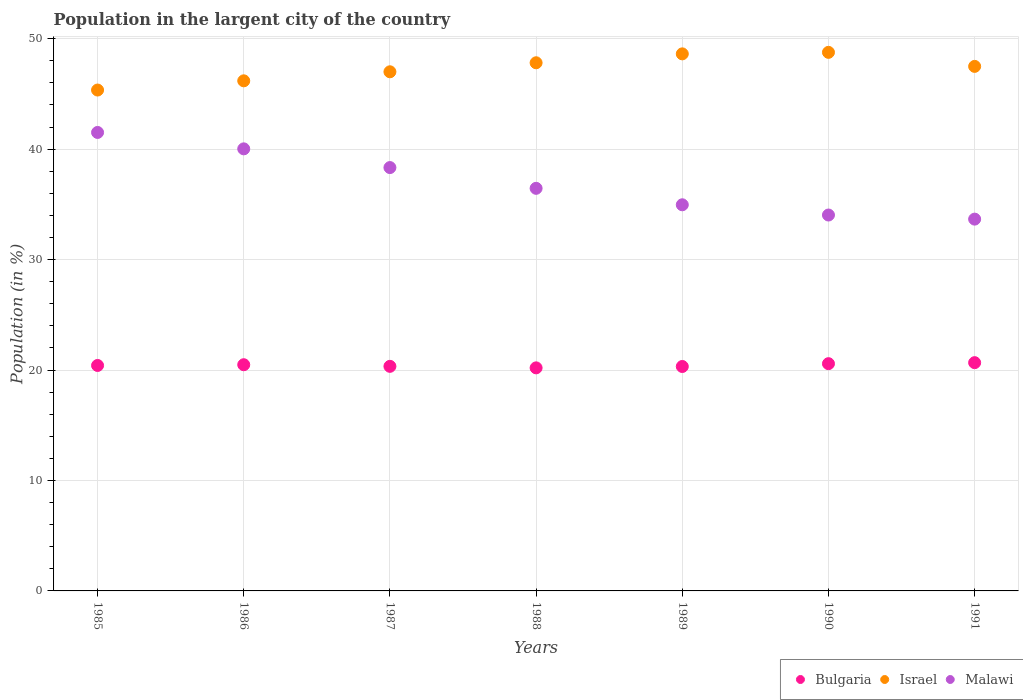How many different coloured dotlines are there?
Your answer should be very brief. 3. What is the percentage of population in the largent city in Israel in 1990?
Keep it short and to the point. 48.77. Across all years, what is the maximum percentage of population in the largent city in Bulgaria?
Ensure brevity in your answer.  20.67. Across all years, what is the minimum percentage of population in the largent city in Israel?
Your answer should be compact. 45.35. In which year was the percentage of population in the largent city in Israel maximum?
Offer a terse response. 1990. What is the total percentage of population in the largent city in Israel in the graph?
Give a very brief answer. 331.25. What is the difference between the percentage of population in the largent city in Israel in 1987 and that in 1990?
Your answer should be very brief. -1.76. What is the difference between the percentage of population in the largent city in Malawi in 1986 and the percentage of population in the largent city in Israel in 1990?
Provide a short and direct response. -8.74. What is the average percentage of population in the largent city in Bulgaria per year?
Offer a terse response. 20.43. In the year 1988, what is the difference between the percentage of population in the largent city in Israel and percentage of population in the largent city in Malawi?
Keep it short and to the point. 11.37. What is the ratio of the percentage of population in the largent city in Israel in 1986 to that in 1989?
Provide a short and direct response. 0.95. Is the difference between the percentage of population in the largent city in Israel in 1987 and 1989 greater than the difference between the percentage of population in the largent city in Malawi in 1987 and 1989?
Give a very brief answer. No. What is the difference between the highest and the second highest percentage of population in the largent city in Malawi?
Provide a short and direct response. 1.49. What is the difference between the highest and the lowest percentage of population in the largent city in Bulgaria?
Ensure brevity in your answer.  0.47. Is the sum of the percentage of population in the largent city in Israel in 1987 and 1991 greater than the maximum percentage of population in the largent city in Malawi across all years?
Your response must be concise. Yes. Is it the case that in every year, the sum of the percentage of population in the largent city in Malawi and percentage of population in the largent city in Israel  is greater than the percentage of population in the largent city in Bulgaria?
Your answer should be compact. Yes. Is the percentage of population in the largent city in Bulgaria strictly greater than the percentage of population in the largent city in Malawi over the years?
Your answer should be very brief. No. Is the percentage of population in the largent city in Israel strictly less than the percentage of population in the largent city in Bulgaria over the years?
Give a very brief answer. No. What is the difference between two consecutive major ticks on the Y-axis?
Offer a very short reply. 10. Are the values on the major ticks of Y-axis written in scientific E-notation?
Make the answer very short. No. Does the graph contain grids?
Your answer should be compact. Yes. Where does the legend appear in the graph?
Provide a short and direct response. Bottom right. How many legend labels are there?
Your response must be concise. 3. How are the legend labels stacked?
Offer a very short reply. Horizontal. What is the title of the graph?
Keep it short and to the point. Population in the largent city of the country. Does "Venezuela" appear as one of the legend labels in the graph?
Give a very brief answer. No. What is the label or title of the X-axis?
Provide a short and direct response. Years. What is the label or title of the Y-axis?
Ensure brevity in your answer.  Population (in %). What is the Population (in %) in Bulgaria in 1985?
Your response must be concise. 20.41. What is the Population (in %) in Israel in 1985?
Offer a terse response. 45.35. What is the Population (in %) of Malawi in 1985?
Provide a short and direct response. 41.51. What is the Population (in %) in Bulgaria in 1986?
Offer a terse response. 20.48. What is the Population (in %) in Israel in 1986?
Your answer should be compact. 46.19. What is the Population (in %) in Malawi in 1986?
Your answer should be compact. 40.03. What is the Population (in %) of Bulgaria in 1987?
Your response must be concise. 20.33. What is the Population (in %) of Israel in 1987?
Offer a terse response. 47.01. What is the Population (in %) of Malawi in 1987?
Offer a very short reply. 38.33. What is the Population (in %) of Bulgaria in 1988?
Your response must be concise. 20.2. What is the Population (in %) of Israel in 1988?
Your answer should be very brief. 47.82. What is the Population (in %) in Malawi in 1988?
Your response must be concise. 36.45. What is the Population (in %) of Bulgaria in 1989?
Give a very brief answer. 20.32. What is the Population (in %) in Israel in 1989?
Provide a short and direct response. 48.63. What is the Population (in %) of Malawi in 1989?
Give a very brief answer. 34.96. What is the Population (in %) of Bulgaria in 1990?
Provide a succinct answer. 20.58. What is the Population (in %) of Israel in 1990?
Give a very brief answer. 48.77. What is the Population (in %) of Malawi in 1990?
Your response must be concise. 34.04. What is the Population (in %) of Bulgaria in 1991?
Offer a terse response. 20.67. What is the Population (in %) of Israel in 1991?
Your answer should be very brief. 47.49. What is the Population (in %) in Malawi in 1991?
Offer a very short reply. 33.66. Across all years, what is the maximum Population (in %) in Bulgaria?
Keep it short and to the point. 20.67. Across all years, what is the maximum Population (in %) of Israel?
Your answer should be compact. 48.77. Across all years, what is the maximum Population (in %) in Malawi?
Make the answer very short. 41.51. Across all years, what is the minimum Population (in %) of Bulgaria?
Give a very brief answer. 20.2. Across all years, what is the minimum Population (in %) in Israel?
Keep it short and to the point. 45.35. Across all years, what is the minimum Population (in %) of Malawi?
Your answer should be very brief. 33.66. What is the total Population (in %) of Bulgaria in the graph?
Give a very brief answer. 142.99. What is the total Population (in %) in Israel in the graph?
Your answer should be compact. 331.25. What is the total Population (in %) in Malawi in the graph?
Make the answer very short. 258.99. What is the difference between the Population (in %) of Bulgaria in 1985 and that in 1986?
Ensure brevity in your answer.  -0.07. What is the difference between the Population (in %) of Israel in 1985 and that in 1986?
Keep it short and to the point. -0.83. What is the difference between the Population (in %) in Malawi in 1985 and that in 1986?
Make the answer very short. 1.49. What is the difference between the Population (in %) in Bulgaria in 1985 and that in 1987?
Your answer should be very brief. 0.08. What is the difference between the Population (in %) in Israel in 1985 and that in 1987?
Make the answer very short. -1.65. What is the difference between the Population (in %) of Malawi in 1985 and that in 1987?
Keep it short and to the point. 3.18. What is the difference between the Population (in %) of Bulgaria in 1985 and that in 1988?
Provide a short and direct response. 0.22. What is the difference between the Population (in %) in Israel in 1985 and that in 1988?
Your response must be concise. -2.47. What is the difference between the Population (in %) of Malawi in 1985 and that in 1988?
Offer a terse response. 5.06. What is the difference between the Population (in %) in Bulgaria in 1985 and that in 1989?
Make the answer very short. 0.09. What is the difference between the Population (in %) in Israel in 1985 and that in 1989?
Ensure brevity in your answer.  -3.28. What is the difference between the Population (in %) of Malawi in 1985 and that in 1989?
Provide a succinct answer. 6.55. What is the difference between the Population (in %) of Bulgaria in 1985 and that in 1990?
Give a very brief answer. -0.16. What is the difference between the Population (in %) of Israel in 1985 and that in 1990?
Your answer should be compact. -3.41. What is the difference between the Population (in %) of Malawi in 1985 and that in 1990?
Ensure brevity in your answer.  7.48. What is the difference between the Population (in %) of Bulgaria in 1985 and that in 1991?
Your answer should be very brief. -0.25. What is the difference between the Population (in %) in Israel in 1985 and that in 1991?
Provide a short and direct response. -2.14. What is the difference between the Population (in %) in Malawi in 1985 and that in 1991?
Ensure brevity in your answer.  7.85. What is the difference between the Population (in %) in Bulgaria in 1986 and that in 1987?
Your answer should be very brief. 0.15. What is the difference between the Population (in %) of Israel in 1986 and that in 1987?
Offer a terse response. -0.82. What is the difference between the Population (in %) of Malawi in 1986 and that in 1987?
Your answer should be compact. 1.69. What is the difference between the Population (in %) of Bulgaria in 1986 and that in 1988?
Offer a very short reply. 0.28. What is the difference between the Population (in %) in Israel in 1986 and that in 1988?
Make the answer very short. -1.63. What is the difference between the Population (in %) of Malawi in 1986 and that in 1988?
Your answer should be compact. 3.57. What is the difference between the Population (in %) in Bulgaria in 1986 and that in 1989?
Offer a very short reply. 0.16. What is the difference between the Population (in %) in Israel in 1986 and that in 1989?
Your answer should be compact. -2.44. What is the difference between the Population (in %) in Malawi in 1986 and that in 1989?
Offer a very short reply. 5.06. What is the difference between the Population (in %) in Bulgaria in 1986 and that in 1990?
Your answer should be very brief. -0.1. What is the difference between the Population (in %) in Israel in 1986 and that in 1990?
Give a very brief answer. -2.58. What is the difference between the Population (in %) in Malawi in 1986 and that in 1990?
Your answer should be compact. 5.99. What is the difference between the Population (in %) of Bulgaria in 1986 and that in 1991?
Your answer should be compact. -0.19. What is the difference between the Population (in %) in Israel in 1986 and that in 1991?
Keep it short and to the point. -1.31. What is the difference between the Population (in %) in Malawi in 1986 and that in 1991?
Make the answer very short. 6.36. What is the difference between the Population (in %) of Bulgaria in 1987 and that in 1988?
Offer a very short reply. 0.14. What is the difference between the Population (in %) of Israel in 1987 and that in 1988?
Provide a short and direct response. -0.82. What is the difference between the Population (in %) of Malawi in 1987 and that in 1988?
Provide a short and direct response. 1.88. What is the difference between the Population (in %) of Bulgaria in 1987 and that in 1989?
Your answer should be very brief. 0.01. What is the difference between the Population (in %) of Israel in 1987 and that in 1989?
Keep it short and to the point. -1.62. What is the difference between the Population (in %) of Malawi in 1987 and that in 1989?
Your answer should be very brief. 3.37. What is the difference between the Population (in %) in Bulgaria in 1987 and that in 1990?
Ensure brevity in your answer.  -0.24. What is the difference between the Population (in %) of Israel in 1987 and that in 1990?
Your answer should be compact. -1.76. What is the difference between the Population (in %) of Malawi in 1987 and that in 1990?
Provide a short and direct response. 4.3. What is the difference between the Population (in %) of Bulgaria in 1987 and that in 1991?
Keep it short and to the point. -0.33. What is the difference between the Population (in %) of Israel in 1987 and that in 1991?
Offer a terse response. -0.49. What is the difference between the Population (in %) in Malawi in 1987 and that in 1991?
Your answer should be compact. 4.67. What is the difference between the Population (in %) of Bulgaria in 1988 and that in 1989?
Offer a very short reply. -0.12. What is the difference between the Population (in %) of Israel in 1988 and that in 1989?
Your response must be concise. -0.81. What is the difference between the Population (in %) of Malawi in 1988 and that in 1989?
Offer a very short reply. 1.49. What is the difference between the Population (in %) in Bulgaria in 1988 and that in 1990?
Your response must be concise. -0.38. What is the difference between the Population (in %) of Israel in 1988 and that in 1990?
Your answer should be very brief. -0.94. What is the difference between the Population (in %) of Malawi in 1988 and that in 1990?
Your answer should be compact. 2.42. What is the difference between the Population (in %) of Bulgaria in 1988 and that in 1991?
Provide a succinct answer. -0.47. What is the difference between the Population (in %) of Israel in 1988 and that in 1991?
Your response must be concise. 0.33. What is the difference between the Population (in %) in Malawi in 1988 and that in 1991?
Offer a very short reply. 2.79. What is the difference between the Population (in %) of Bulgaria in 1989 and that in 1990?
Your answer should be compact. -0.26. What is the difference between the Population (in %) of Israel in 1989 and that in 1990?
Ensure brevity in your answer.  -0.14. What is the difference between the Population (in %) in Malawi in 1989 and that in 1990?
Keep it short and to the point. 0.93. What is the difference between the Population (in %) of Bulgaria in 1989 and that in 1991?
Make the answer very short. -0.35. What is the difference between the Population (in %) in Israel in 1989 and that in 1991?
Your answer should be very brief. 1.13. What is the difference between the Population (in %) of Malawi in 1989 and that in 1991?
Provide a short and direct response. 1.3. What is the difference between the Population (in %) in Bulgaria in 1990 and that in 1991?
Your answer should be compact. -0.09. What is the difference between the Population (in %) in Israel in 1990 and that in 1991?
Provide a succinct answer. 1.27. What is the difference between the Population (in %) in Malawi in 1990 and that in 1991?
Your answer should be very brief. 0.37. What is the difference between the Population (in %) in Bulgaria in 1985 and the Population (in %) in Israel in 1986?
Provide a short and direct response. -25.77. What is the difference between the Population (in %) of Bulgaria in 1985 and the Population (in %) of Malawi in 1986?
Your response must be concise. -19.61. What is the difference between the Population (in %) of Israel in 1985 and the Population (in %) of Malawi in 1986?
Provide a short and direct response. 5.32. What is the difference between the Population (in %) in Bulgaria in 1985 and the Population (in %) in Israel in 1987?
Give a very brief answer. -26.59. What is the difference between the Population (in %) in Bulgaria in 1985 and the Population (in %) in Malawi in 1987?
Ensure brevity in your answer.  -17.92. What is the difference between the Population (in %) of Israel in 1985 and the Population (in %) of Malawi in 1987?
Keep it short and to the point. 7.02. What is the difference between the Population (in %) in Bulgaria in 1985 and the Population (in %) in Israel in 1988?
Ensure brevity in your answer.  -27.41. What is the difference between the Population (in %) in Bulgaria in 1985 and the Population (in %) in Malawi in 1988?
Offer a very short reply. -16.04. What is the difference between the Population (in %) in Israel in 1985 and the Population (in %) in Malawi in 1988?
Your answer should be very brief. 8.9. What is the difference between the Population (in %) in Bulgaria in 1985 and the Population (in %) in Israel in 1989?
Ensure brevity in your answer.  -28.21. What is the difference between the Population (in %) of Bulgaria in 1985 and the Population (in %) of Malawi in 1989?
Provide a short and direct response. -14.55. What is the difference between the Population (in %) of Israel in 1985 and the Population (in %) of Malawi in 1989?
Offer a terse response. 10.39. What is the difference between the Population (in %) of Bulgaria in 1985 and the Population (in %) of Israel in 1990?
Give a very brief answer. -28.35. What is the difference between the Population (in %) in Bulgaria in 1985 and the Population (in %) in Malawi in 1990?
Your answer should be very brief. -13.62. What is the difference between the Population (in %) of Israel in 1985 and the Population (in %) of Malawi in 1990?
Your response must be concise. 11.32. What is the difference between the Population (in %) of Bulgaria in 1985 and the Population (in %) of Israel in 1991?
Provide a succinct answer. -27.08. What is the difference between the Population (in %) of Bulgaria in 1985 and the Population (in %) of Malawi in 1991?
Ensure brevity in your answer.  -13.25. What is the difference between the Population (in %) in Israel in 1985 and the Population (in %) in Malawi in 1991?
Offer a terse response. 11.69. What is the difference between the Population (in %) of Bulgaria in 1986 and the Population (in %) of Israel in 1987?
Give a very brief answer. -26.52. What is the difference between the Population (in %) of Bulgaria in 1986 and the Population (in %) of Malawi in 1987?
Offer a terse response. -17.85. What is the difference between the Population (in %) of Israel in 1986 and the Population (in %) of Malawi in 1987?
Make the answer very short. 7.85. What is the difference between the Population (in %) of Bulgaria in 1986 and the Population (in %) of Israel in 1988?
Give a very brief answer. -27.34. What is the difference between the Population (in %) of Bulgaria in 1986 and the Population (in %) of Malawi in 1988?
Keep it short and to the point. -15.97. What is the difference between the Population (in %) in Israel in 1986 and the Population (in %) in Malawi in 1988?
Offer a very short reply. 9.73. What is the difference between the Population (in %) in Bulgaria in 1986 and the Population (in %) in Israel in 1989?
Offer a terse response. -28.15. What is the difference between the Population (in %) of Bulgaria in 1986 and the Population (in %) of Malawi in 1989?
Keep it short and to the point. -14.48. What is the difference between the Population (in %) of Israel in 1986 and the Population (in %) of Malawi in 1989?
Provide a short and direct response. 11.22. What is the difference between the Population (in %) of Bulgaria in 1986 and the Population (in %) of Israel in 1990?
Your response must be concise. -28.28. What is the difference between the Population (in %) in Bulgaria in 1986 and the Population (in %) in Malawi in 1990?
Offer a very short reply. -13.55. What is the difference between the Population (in %) of Israel in 1986 and the Population (in %) of Malawi in 1990?
Provide a succinct answer. 12.15. What is the difference between the Population (in %) of Bulgaria in 1986 and the Population (in %) of Israel in 1991?
Keep it short and to the point. -27.01. What is the difference between the Population (in %) in Bulgaria in 1986 and the Population (in %) in Malawi in 1991?
Offer a terse response. -13.18. What is the difference between the Population (in %) in Israel in 1986 and the Population (in %) in Malawi in 1991?
Ensure brevity in your answer.  12.52. What is the difference between the Population (in %) of Bulgaria in 1987 and the Population (in %) of Israel in 1988?
Make the answer very short. -27.49. What is the difference between the Population (in %) of Bulgaria in 1987 and the Population (in %) of Malawi in 1988?
Ensure brevity in your answer.  -16.12. What is the difference between the Population (in %) of Israel in 1987 and the Population (in %) of Malawi in 1988?
Your response must be concise. 10.55. What is the difference between the Population (in %) of Bulgaria in 1987 and the Population (in %) of Israel in 1989?
Provide a succinct answer. -28.29. What is the difference between the Population (in %) in Bulgaria in 1987 and the Population (in %) in Malawi in 1989?
Offer a very short reply. -14.63. What is the difference between the Population (in %) of Israel in 1987 and the Population (in %) of Malawi in 1989?
Make the answer very short. 12.04. What is the difference between the Population (in %) in Bulgaria in 1987 and the Population (in %) in Israel in 1990?
Provide a succinct answer. -28.43. What is the difference between the Population (in %) of Bulgaria in 1987 and the Population (in %) of Malawi in 1990?
Give a very brief answer. -13.7. What is the difference between the Population (in %) of Israel in 1987 and the Population (in %) of Malawi in 1990?
Offer a terse response. 12.97. What is the difference between the Population (in %) of Bulgaria in 1987 and the Population (in %) of Israel in 1991?
Make the answer very short. -27.16. What is the difference between the Population (in %) in Bulgaria in 1987 and the Population (in %) in Malawi in 1991?
Your response must be concise. -13.33. What is the difference between the Population (in %) in Israel in 1987 and the Population (in %) in Malawi in 1991?
Make the answer very short. 13.34. What is the difference between the Population (in %) of Bulgaria in 1988 and the Population (in %) of Israel in 1989?
Ensure brevity in your answer.  -28.43. What is the difference between the Population (in %) of Bulgaria in 1988 and the Population (in %) of Malawi in 1989?
Provide a short and direct response. -14.77. What is the difference between the Population (in %) of Israel in 1988 and the Population (in %) of Malawi in 1989?
Ensure brevity in your answer.  12.86. What is the difference between the Population (in %) of Bulgaria in 1988 and the Population (in %) of Israel in 1990?
Offer a very short reply. -28.57. What is the difference between the Population (in %) of Bulgaria in 1988 and the Population (in %) of Malawi in 1990?
Provide a succinct answer. -13.84. What is the difference between the Population (in %) of Israel in 1988 and the Population (in %) of Malawi in 1990?
Provide a succinct answer. 13.79. What is the difference between the Population (in %) in Bulgaria in 1988 and the Population (in %) in Israel in 1991?
Your answer should be very brief. -27.3. What is the difference between the Population (in %) of Bulgaria in 1988 and the Population (in %) of Malawi in 1991?
Offer a terse response. -13.47. What is the difference between the Population (in %) of Israel in 1988 and the Population (in %) of Malawi in 1991?
Make the answer very short. 14.16. What is the difference between the Population (in %) in Bulgaria in 1989 and the Population (in %) in Israel in 1990?
Give a very brief answer. -28.44. What is the difference between the Population (in %) in Bulgaria in 1989 and the Population (in %) in Malawi in 1990?
Make the answer very short. -13.71. What is the difference between the Population (in %) in Israel in 1989 and the Population (in %) in Malawi in 1990?
Give a very brief answer. 14.59. What is the difference between the Population (in %) of Bulgaria in 1989 and the Population (in %) of Israel in 1991?
Give a very brief answer. -27.17. What is the difference between the Population (in %) of Bulgaria in 1989 and the Population (in %) of Malawi in 1991?
Ensure brevity in your answer.  -13.34. What is the difference between the Population (in %) in Israel in 1989 and the Population (in %) in Malawi in 1991?
Provide a short and direct response. 14.96. What is the difference between the Population (in %) in Bulgaria in 1990 and the Population (in %) in Israel in 1991?
Your answer should be very brief. -26.92. What is the difference between the Population (in %) of Bulgaria in 1990 and the Population (in %) of Malawi in 1991?
Provide a short and direct response. -13.09. What is the difference between the Population (in %) of Israel in 1990 and the Population (in %) of Malawi in 1991?
Provide a short and direct response. 15.1. What is the average Population (in %) in Bulgaria per year?
Your answer should be very brief. 20.43. What is the average Population (in %) of Israel per year?
Provide a short and direct response. 47.32. What is the average Population (in %) in Malawi per year?
Provide a short and direct response. 37. In the year 1985, what is the difference between the Population (in %) of Bulgaria and Population (in %) of Israel?
Your answer should be very brief. -24.94. In the year 1985, what is the difference between the Population (in %) in Bulgaria and Population (in %) in Malawi?
Keep it short and to the point. -21.1. In the year 1985, what is the difference between the Population (in %) in Israel and Population (in %) in Malawi?
Provide a succinct answer. 3.84. In the year 1986, what is the difference between the Population (in %) in Bulgaria and Population (in %) in Israel?
Your answer should be compact. -25.71. In the year 1986, what is the difference between the Population (in %) of Bulgaria and Population (in %) of Malawi?
Keep it short and to the point. -19.55. In the year 1986, what is the difference between the Population (in %) of Israel and Population (in %) of Malawi?
Provide a short and direct response. 6.16. In the year 1987, what is the difference between the Population (in %) of Bulgaria and Population (in %) of Israel?
Keep it short and to the point. -26.67. In the year 1987, what is the difference between the Population (in %) of Bulgaria and Population (in %) of Malawi?
Ensure brevity in your answer.  -18. In the year 1987, what is the difference between the Population (in %) of Israel and Population (in %) of Malawi?
Offer a terse response. 8.67. In the year 1988, what is the difference between the Population (in %) in Bulgaria and Population (in %) in Israel?
Make the answer very short. -27.62. In the year 1988, what is the difference between the Population (in %) of Bulgaria and Population (in %) of Malawi?
Give a very brief answer. -16.26. In the year 1988, what is the difference between the Population (in %) of Israel and Population (in %) of Malawi?
Your response must be concise. 11.37. In the year 1989, what is the difference between the Population (in %) in Bulgaria and Population (in %) in Israel?
Offer a very short reply. -28.31. In the year 1989, what is the difference between the Population (in %) of Bulgaria and Population (in %) of Malawi?
Give a very brief answer. -14.64. In the year 1989, what is the difference between the Population (in %) of Israel and Population (in %) of Malawi?
Provide a short and direct response. 13.67. In the year 1990, what is the difference between the Population (in %) of Bulgaria and Population (in %) of Israel?
Offer a terse response. -28.19. In the year 1990, what is the difference between the Population (in %) of Bulgaria and Population (in %) of Malawi?
Your answer should be very brief. -13.46. In the year 1990, what is the difference between the Population (in %) in Israel and Population (in %) in Malawi?
Provide a short and direct response. 14.73. In the year 1991, what is the difference between the Population (in %) in Bulgaria and Population (in %) in Israel?
Give a very brief answer. -26.83. In the year 1991, what is the difference between the Population (in %) of Bulgaria and Population (in %) of Malawi?
Ensure brevity in your answer.  -13. In the year 1991, what is the difference between the Population (in %) of Israel and Population (in %) of Malawi?
Give a very brief answer. 13.83. What is the ratio of the Population (in %) of Israel in 1985 to that in 1986?
Provide a succinct answer. 0.98. What is the ratio of the Population (in %) of Malawi in 1985 to that in 1986?
Give a very brief answer. 1.04. What is the ratio of the Population (in %) in Israel in 1985 to that in 1987?
Offer a very short reply. 0.96. What is the ratio of the Population (in %) in Malawi in 1985 to that in 1987?
Your response must be concise. 1.08. What is the ratio of the Population (in %) in Bulgaria in 1985 to that in 1988?
Your answer should be compact. 1.01. What is the ratio of the Population (in %) in Israel in 1985 to that in 1988?
Your answer should be very brief. 0.95. What is the ratio of the Population (in %) of Malawi in 1985 to that in 1988?
Make the answer very short. 1.14. What is the ratio of the Population (in %) of Bulgaria in 1985 to that in 1989?
Offer a terse response. 1. What is the ratio of the Population (in %) of Israel in 1985 to that in 1989?
Your response must be concise. 0.93. What is the ratio of the Population (in %) in Malawi in 1985 to that in 1989?
Provide a short and direct response. 1.19. What is the ratio of the Population (in %) in Bulgaria in 1985 to that in 1990?
Your answer should be compact. 0.99. What is the ratio of the Population (in %) in Israel in 1985 to that in 1990?
Your response must be concise. 0.93. What is the ratio of the Population (in %) in Malawi in 1985 to that in 1990?
Your answer should be compact. 1.22. What is the ratio of the Population (in %) in Bulgaria in 1985 to that in 1991?
Your response must be concise. 0.99. What is the ratio of the Population (in %) of Israel in 1985 to that in 1991?
Offer a very short reply. 0.95. What is the ratio of the Population (in %) of Malawi in 1985 to that in 1991?
Give a very brief answer. 1.23. What is the ratio of the Population (in %) in Israel in 1986 to that in 1987?
Provide a short and direct response. 0.98. What is the ratio of the Population (in %) of Malawi in 1986 to that in 1987?
Provide a succinct answer. 1.04. What is the ratio of the Population (in %) in Bulgaria in 1986 to that in 1988?
Keep it short and to the point. 1.01. What is the ratio of the Population (in %) of Israel in 1986 to that in 1988?
Provide a short and direct response. 0.97. What is the ratio of the Population (in %) in Malawi in 1986 to that in 1988?
Your answer should be compact. 1.1. What is the ratio of the Population (in %) in Bulgaria in 1986 to that in 1989?
Make the answer very short. 1.01. What is the ratio of the Population (in %) of Israel in 1986 to that in 1989?
Make the answer very short. 0.95. What is the ratio of the Population (in %) of Malawi in 1986 to that in 1989?
Ensure brevity in your answer.  1.14. What is the ratio of the Population (in %) in Bulgaria in 1986 to that in 1990?
Give a very brief answer. 1. What is the ratio of the Population (in %) in Israel in 1986 to that in 1990?
Ensure brevity in your answer.  0.95. What is the ratio of the Population (in %) of Malawi in 1986 to that in 1990?
Offer a very short reply. 1.18. What is the ratio of the Population (in %) in Bulgaria in 1986 to that in 1991?
Provide a succinct answer. 0.99. What is the ratio of the Population (in %) of Israel in 1986 to that in 1991?
Offer a very short reply. 0.97. What is the ratio of the Population (in %) in Malawi in 1986 to that in 1991?
Offer a terse response. 1.19. What is the ratio of the Population (in %) of Bulgaria in 1987 to that in 1988?
Ensure brevity in your answer.  1.01. What is the ratio of the Population (in %) of Israel in 1987 to that in 1988?
Your answer should be very brief. 0.98. What is the ratio of the Population (in %) in Malawi in 1987 to that in 1988?
Provide a succinct answer. 1.05. What is the ratio of the Population (in %) in Bulgaria in 1987 to that in 1989?
Your response must be concise. 1. What is the ratio of the Population (in %) of Israel in 1987 to that in 1989?
Offer a terse response. 0.97. What is the ratio of the Population (in %) of Malawi in 1987 to that in 1989?
Your response must be concise. 1.1. What is the ratio of the Population (in %) in Bulgaria in 1987 to that in 1990?
Provide a succinct answer. 0.99. What is the ratio of the Population (in %) in Israel in 1987 to that in 1990?
Your answer should be compact. 0.96. What is the ratio of the Population (in %) of Malawi in 1987 to that in 1990?
Keep it short and to the point. 1.13. What is the ratio of the Population (in %) of Bulgaria in 1987 to that in 1991?
Offer a terse response. 0.98. What is the ratio of the Population (in %) in Malawi in 1987 to that in 1991?
Keep it short and to the point. 1.14. What is the ratio of the Population (in %) in Bulgaria in 1988 to that in 1989?
Give a very brief answer. 0.99. What is the ratio of the Population (in %) in Israel in 1988 to that in 1989?
Your response must be concise. 0.98. What is the ratio of the Population (in %) of Malawi in 1988 to that in 1989?
Make the answer very short. 1.04. What is the ratio of the Population (in %) of Bulgaria in 1988 to that in 1990?
Give a very brief answer. 0.98. What is the ratio of the Population (in %) in Israel in 1988 to that in 1990?
Your answer should be compact. 0.98. What is the ratio of the Population (in %) of Malawi in 1988 to that in 1990?
Your answer should be very brief. 1.07. What is the ratio of the Population (in %) of Bulgaria in 1988 to that in 1991?
Provide a short and direct response. 0.98. What is the ratio of the Population (in %) in Malawi in 1988 to that in 1991?
Your response must be concise. 1.08. What is the ratio of the Population (in %) in Bulgaria in 1989 to that in 1990?
Make the answer very short. 0.99. What is the ratio of the Population (in %) in Malawi in 1989 to that in 1990?
Your answer should be compact. 1.03. What is the ratio of the Population (in %) in Bulgaria in 1989 to that in 1991?
Ensure brevity in your answer.  0.98. What is the ratio of the Population (in %) of Israel in 1989 to that in 1991?
Provide a short and direct response. 1.02. What is the ratio of the Population (in %) of Malawi in 1989 to that in 1991?
Ensure brevity in your answer.  1.04. What is the ratio of the Population (in %) in Bulgaria in 1990 to that in 1991?
Offer a terse response. 1. What is the ratio of the Population (in %) of Israel in 1990 to that in 1991?
Make the answer very short. 1.03. What is the difference between the highest and the second highest Population (in %) of Bulgaria?
Your answer should be compact. 0.09. What is the difference between the highest and the second highest Population (in %) in Israel?
Your response must be concise. 0.14. What is the difference between the highest and the second highest Population (in %) in Malawi?
Make the answer very short. 1.49. What is the difference between the highest and the lowest Population (in %) in Bulgaria?
Your answer should be very brief. 0.47. What is the difference between the highest and the lowest Population (in %) in Israel?
Provide a succinct answer. 3.41. What is the difference between the highest and the lowest Population (in %) of Malawi?
Offer a very short reply. 7.85. 